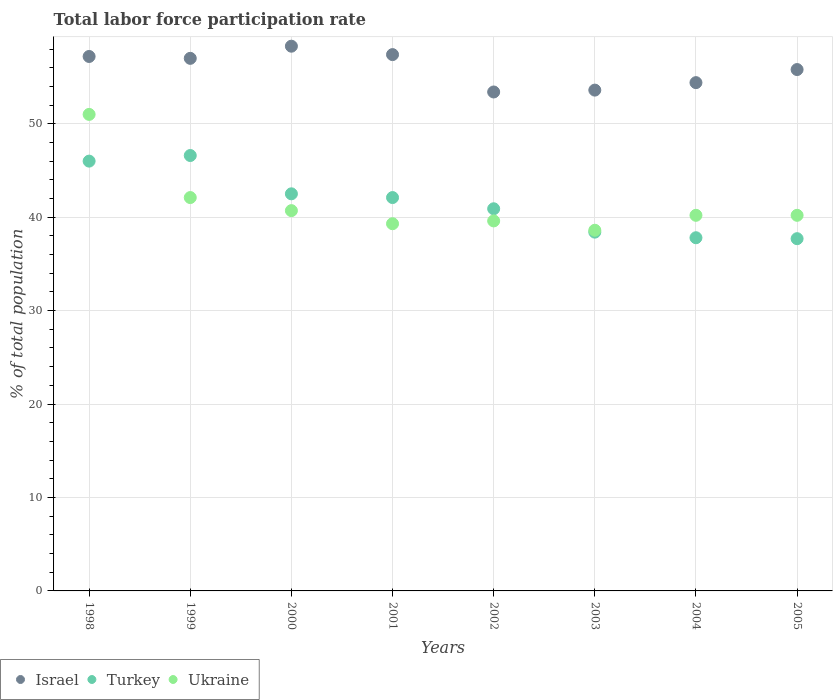How many different coloured dotlines are there?
Your response must be concise. 3. What is the total labor force participation rate in Turkey in 2004?
Keep it short and to the point. 37.8. Across all years, what is the maximum total labor force participation rate in Turkey?
Your answer should be very brief. 46.6. Across all years, what is the minimum total labor force participation rate in Ukraine?
Offer a very short reply. 38.6. In which year was the total labor force participation rate in Israel maximum?
Give a very brief answer. 2000. In which year was the total labor force participation rate in Israel minimum?
Your response must be concise. 2002. What is the total total labor force participation rate in Israel in the graph?
Your answer should be very brief. 447.1. What is the difference between the total labor force participation rate in Israel in 1999 and that in 2001?
Make the answer very short. -0.4. What is the difference between the total labor force participation rate in Ukraine in 1998 and the total labor force participation rate in Israel in 2000?
Your response must be concise. -7.3. What is the average total labor force participation rate in Ukraine per year?
Ensure brevity in your answer.  41.46. In the year 2001, what is the difference between the total labor force participation rate in Israel and total labor force participation rate in Ukraine?
Make the answer very short. 18.1. What is the ratio of the total labor force participation rate in Ukraine in 1999 to that in 2005?
Keep it short and to the point. 1.05. What is the difference between the highest and the second highest total labor force participation rate in Ukraine?
Ensure brevity in your answer.  8.9. What is the difference between the highest and the lowest total labor force participation rate in Israel?
Make the answer very short. 4.9. In how many years, is the total labor force participation rate in Turkey greater than the average total labor force participation rate in Turkey taken over all years?
Offer a very short reply. 4. Is the sum of the total labor force participation rate in Israel in 1998 and 2001 greater than the maximum total labor force participation rate in Ukraine across all years?
Offer a terse response. Yes. Is the total labor force participation rate in Ukraine strictly greater than the total labor force participation rate in Israel over the years?
Your answer should be very brief. No. Is the total labor force participation rate in Israel strictly less than the total labor force participation rate in Turkey over the years?
Ensure brevity in your answer.  No. How many years are there in the graph?
Your answer should be compact. 8. What is the difference between two consecutive major ticks on the Y-axis?
Give a very brief answer. 10. What is the title of the graph?
Ensure brevity in your answer.  Total labor force participation rate. Does "Chile" appear as one of the legend labels in the graph?
Provide a succinct answer. No. What is the label or title of the X-axis?
Provide a succinct answer. Years. What is the label or title of the Y-axis?
Offer a very short reply. % of total population. What is the % of total population of Israel in 1998?
Your response must be concise. 57.2. What is the % of total population in Ukraine in 1998?
Keep it short and to the point. 51. What is the % of total population of Israel in 1999?
Your answer should be compact. 57. What is the % of total population of Turkey in 1999?
Ensure brevity in your answer.  46.6. What is the % of total population of Ukraine in 1999?
Your response must be concise. 42.1. What is the % of total population of Israel in 2000?
Provide a succinct answer. 58.3. What is the % of total population of Turkey in 2000?
Make the answer very short. 42.5. What is the % of total population of Ukraine in 2000?
Your answer should be compact. 40.7. What is the % of total population in Israel in 2001?
Provide a short and direct response. 57.4. What is the % of total population in Turkey in 2001?
Provide a succinct answer. 42.1. What is the % of total population in Ukraine in 2001?
Provide a short and direct response. 39.3. What is the % of total population of Israel in 2002?
Make the answer very short. 53.4. What is the % of total population in Turkey in 2002?
Give a very brief answer. 40.9. What is the % of total population in Ukraine in 2002?
Ensure brevity in your answer.  39.6. What is the % of total population of Israel in 2003?
Keep it short and to the point. 53.6. What is the % of total population in Turkey in 2003?
Your response must be concise. 38.4. What is the % of total population in Ukraine in 2003?
Your answer should be very brief. 38.6. What is the % of total population of Israel in 2004?
Offer a terse response. 54.4. What is the % of total population of Turkey in 2004?
Provide a succinct answer. 37.8. What is the % of total population of Ukraine in 2004?
Offer a very short reply. 40.2. What is the % of total population of Israel in 2005?
Offer a terse response. 55.8. What is the % of total population in Turkey in 2005?
Your answer should be very brief. 37.7. What is the % of total population in Ukraine in 2005?
Your answer should be very brief. 40.2. Across all years, what is the maximum % of total population of Israel?
Your answer should be very brief. 58.3. Across all years, what is the maximum % of total population in Turkey?
Make the answer very short. 46.6. Across all years, what is the maximum % of total population of Ukraine?
Your response must be concise. 51. Across all years, what is the minimum % of total population in Israel?
Ensure brevity in your answer.  53.4. Across all years, what is the minimum % of total population in Turkey?
Provide a succinct answer. 37.7. Across all years, what is the minimum % of total population in Ukraine?
Your answer should be very brief. 38.6. What is the total % of total population in Israel in the graph?
Your response must be concise. 447.1. What is the total % of total population of Turkey in the graph?
Your answer should be compact. 332. What is the total % of total population in Ukraine in the graph?
Offer a very short reply. 331.7. What is the difference between the % of total population of Israel in 1998 and that in 1999?
Provide a succinct answer. 0.2. What is the difference between the % of total population of Turkey in 1998 and that in 1999?
Ensure brevity in your answer.  -0.6. What is the difference between the % of total population of Ukraine in 1998 and that in 1999?
Offer a terse response. 8.9. What is the difference between the % of total population in Israel in 1998 and that in 2000?
Keep it short and to the point. -1.1. What is the difference between the % of total population of Turkey in 1998 and that in 2000?
Your answer should be compact. 3.5. What is the difference between the % of total population in Ukraine in 1998 and that in 2001?
Provide a short and direct response. 11.7. What is the difference between the % of total population of Israel in 1998 and that in 2003?
Offer a terse response. 3.6. What is the difference between the % of total population in Ukraine in 1998 and that in 2003?
Provide a short and direct response. 12.4. What is the difference between the % of total population of Israel in 1998 and that in 2004?
Ensure brevity in your answer.  2.8. What is the difference between the % of total population of Israel in 1998 and that in 2005?
Provide a short and direct response. 1.4. What is the difference between the % of total population of Ukraine in 1998 and that in 2005?
Offer a terse response. 10.8. What is the difference between the % of total population in Turkey in 1999 and that in 2000?
Ensure brevity in your answer.  4.1. What is the difference between the % of total population of Israel in 1999 and that in 2001?
Offer a very short reply. -0.4. What is the difference between the % of total population of Ukraine in 1999 and that in 2001?
Your response must be concise. 2.8. What is the difference between the % of total population in Israel in 1999 and that in 2002?
Offer a terse response. 3.6. What is the difference between the % of total population in Israel in 1999 and that in 2003?
Offer a very short reply. 3.4. What is the difference between the % of total population in Turkey in 1999 and that in 2003?
Offer a very short reply. 8.2. What is the difference between the % of total population in Ukraine in 1999 and that in 2003?
Offer a terse response. 3.5. What is the difference between the % of total population in Israel in 1999 and that in 2004?
Offer a very short reply. 2.6. What is the difference between the % of total population of Turkey in 1999 and that in 2004?
Offer a very short reply. 8.8. What is the difference between the % of total population in Turkey in 1999 and that in 2005?
Give a very brief answer. 8.9. What is the difference between the % of total population in Turkey in 2000 and that in 2001?
Your response must be concise. 0.4. What is the difference between the % of total population of Ukraine in 2000 and that in 2001?
Make the answer very short. 1.4. What is the difference between the % of total population of Israel in 2000 and that in 2002?
Provide a short and direct response. 4.9. What is the difference between the % of total population of Ukraine in 2000 and that in 2002?
Give a very brief answer. 1.1. What is the difference between the % of total population in Israel in 2000 and that in 2003?
Keep it short and to the point. 4.7. What is the difference between the % of total population in Turkey in 2000 and that in 2003?
Your answer should be compact. 4.1. What is the difference between the % of total population of Ukraine in 2000 and that in 2003?
Ensure brevity in your answer.  2.1. What is the difference between the % of total population in Israel in 2000 and that in 2004?
Offer a terse response. 3.9. What is the difference between the % of total population in Ukraine in 2000 and that in 2004?
Ensure brevity in your answer.  0.5. What is the difference between the % of total population of Israel in 2000 and that in 2005?
Your answer should be very brief. 2.5. What is the difference between the % of total population in Turkey in 2000 and that in 2005?
Offer a terse response. 4.8. What is the difference between the % of total population in Israel in 2001 and that in 2002?
Make the answer very short. 4. What is the difference between the % of total population in Turkey in 2001 and that in 2002?
Offer a very short reply. 1.2. What is the difference between the % of total population in Israel in 2001 and that in 2003?
Keep it short and to the point. 3.8. What is the difference between the % of total population of Israel in 2001 and that in 2004?
Keep it short and to the point. 3. What is the difference between the % of total population of Turkey in 2001 and that in 2004?
Give a very brief answer. 4.3. What is the difference between the % of total population in Ukraine in 2001 and that in 2004?
Your answer should be very brief. -0.9. What is the difference between the % of total population in Israel in 2001 and that in 2005?
Your answer should be compact. 1.6. What is the difference between the % of total population in Turkey in 2001 and that in 2005?
Give a very brief answer. 4.4. What is the difference between the % of total population of Turkey in 2002 and that in 2004?
Your answer should be very brief. 3.1. What is the difference between the % of total population in Ukraine in 2002 and that in 2004?
Provide a succinct answer. -0.6. What is the difference between the % of total population in Israel in 2002 and that in 2005?
Give a very brief answer. -2.4. What is the difference between the % of total population of Turkey in 2002 and that in 2005?
Your answer should be compact. 3.2. What is the difference between the % of total population in Ukraine in 2003 and that in 2004?
Make the answer very short. -1.6. What is the difference between the % of total population of Ukraine in 2003 and that in 2005?
Offer a terse response. -1.6. What is the difference between the % of total population in Israel in 2004 and that in 2005?
Ensure brevity in your answer.  -1.4. What is the difference between the % of total population of Turkey in 2004 and that in 2005?
Provide a short and direct response. 0.1. What is the difference between the % of total population of Israel in 1998 and the % of total population of Turkey in 1999?
Your answer should be compact. 10.6. What is the difference between the % of total population in Israel in 1998 and the % of total population in Turkey in 2000?
Offer a very short reply. 14.7. What is the difference between the % of total population of Israel in 1998 and the % of total population of Ukraine in 2000?
Your answer should be compact. 16.5. What is the difference between the % of total population of Israel in 1998 and the % of total population of Turkey in 2001?
Offer a terse response. 15.1. What is the difference between the % of total population in Israel in 1998 and the % of total population in Ukraine in 2001?
Provide a succinct answer. 17.9. What is the difference between the % of total population of Turkey in 1998 and the % of total population of Ukraine in 2002?
Keep it short and to the point. 6.4. What is the difference between the % of total population in Israel in 1998 and the % of total population in Turkey in 2003?
Keep it short and to the point. 18.8. What is the difference between the % of total population in Turkey in 1998 and the % of total population in Ukraine in 2003?
Provide a short and direct response. 7.4. What is the difference between the % of total population in Israel in 1998 and the % of total population in Turkey in 2004?
Your response must be concise. 19.4. What is the difference between the % of total population in Turkey in 1998 and the % of total population in Ukraine in 2004?
Provide a short and direct response. 5.8. What is the difference between the % of total population of Israel in 1999 and the % of total population of Turkey in 2000?
Make the answer very short. 14.5. What is the difference between the % of total population of Turkey in 1999 and the % of total population of Ukraine in 2000?
Make the answer very short. 5.9. What is the difference between the % of total population of Israel in 1999 and the % of total population of Turkey in 2001?
Make the answer very short. 14.9. What is the difference between the % of total population of Turkey in 1999 and the % of total population of Ukraine in 2001?
Your response must be concise. 7.3. What is the difference between the % of total population in Israel in 1999 and the % of total population in Turkey in 2002?
Offer a very short reply. 16.1. What is the difference between the % of total population in Turkey in 1999 and the % of total population in Ukraine in 2002?
Give a very brief answer. 7. What is the difference between the % of total population in Turkey in 1999 and the % of total population in Ukraine in 2003?
Offer a very short reply. 8. What is the difference between the % of total population in Israel in 1999 and the % of total population in Turkey in 2005?
Your answer should be very brief. 19.3. What is the difference between the % of total population of Israel in 2000 and the % of total population of Turkey in 2004?
Give a very brief answer. 20.5. What is the difference between the % of total population in Israel in 2000 and the % of total population in Ukraine in 2004?
Your response must be concise. 18.1. What is the difference between the % of total population of Israel in 2000 and the % of total population of Turkey in 2005?
Offer a terse response. 20.6. What is the difference between the % of total population in Israel in 2000 and the % of total population in Ukraine in 2005?
Your answer should be very brief. 18.1. What is the difference between the % of total population of Turkey in 2001 and the % of total population of Ukraine in 2002?
Provide a succinct answer. 2.5. What is the difference between the % of total population of Israel in 2001 and the % of total population of Turkey in 2003?
Your answer should be compact. 19. What is the difference between the % of total population in Israel in 2001 and the % of total population in Ukraine in 2003?
Offer a very short reply. 18.8. What is the difference between the % of total population of Turkey in 2001 and the % of total population of Ukraine in 2003?
Ensure brevity in your answer.  3.5. What is the difference between the % of total population in Israel in 2001 and the % of total population in Turkey in 2004?
Offer a very short reply. 19.6. What is the difference between the % of total population of Turkey in 2001 and the % of total population of Ukraine in 2004?
Provide a succinct answer. 1.9. What is the difference between the % of total population of Israel in 2001 and the % of total population of Ukraine in 2005?
Offer a very short reply. 17.2. What is the difference between the % of total population in Turkey in 2001 and the % of total population in Ukraine in 2005?
Your answer should be very brief. 1.9. What is the difference between the % of total population in Israel in 2002 and the % of total population in Turkey in 2003?
Your answer should be compact. 15. What is the difference between the % of total population in Israel in 2002 and the % of total population in Ukraine in 2003?
Offer a very short reply. 14.8. What is the difference between the % of total population in Israel in 2002 and the % of total population in Turkey in 2004?
Give a very brief answer. 15.6. What is the difference between the % of total population in Turkey in 2002 and the % of total population in Ukraine in 2004?
Your answer should be very brief. 0.7. What is the difference between the % of total population of Israel in 2002 and the % of total population of Turkey in 2005?
Provide a succinct answer. 15.7. What is the difference between the % of total population of Israel in 2002 and the % of total population of Ukraine in 2005?
Provide a short and direct response. 13.2. What is the difference between the % of total population of Israel in 2003 and the % of total population of Turkey in 2004?
Provide a short and direct response. 15.8. What is the difference between the % of total population of Israel in 2003 and the % of total population of Turkey in 2005?
Make the answer very short. 15.9. What is the difference between the % of total population of Turkey in 2003 and the % of total population of Ukraine in 2005?
Make the answer very short. -1.8. What is the difference between the % of total population in Israel in 2004 and the % of total population in Turkey in 2005?
Your answer should be very brief. 16.7. What is the difference between the % of total population of Israel in 2004 and the % of total population of Ukraine in 2005?
Provide a succinct answer. 14.2. What is the difference between the % of total population of Turkey in 2004 and the % of total population of Ukraine in 2005?
Your answer should be very brief. -2.4. What is the average % of total population of Israel per year?
Make the answer very short. 55.89. What is the average % of total population in Turkey per year?
Offer a very short reply. 41.5. What is the average % of total population in Ukraine per year?
Give a very brief answer. 41.46. In the year 1998, what is the difference between the % of total population of Israel and % of total population of Turkey?
Offer a terse response. 11.2. In the year 1998, what is the difference between the % of total population of Israel and % of total population of Ukraine?
Your answer should be compact. 6.2. In the year 1999, what is the difference between the % of total population in Turkey and % of total population in Ukraine?
Offer a terse response. 4.5. In the year 2000, what is the difference between the % of total population in Israel and % of total population in Ukraine?
Ensure brevity in your answer.  17.6. In the year 2000, what is the difference between the % of total population of Turkey and % of total population of Ukraine?
Your answer should be very brief. 1.8. In the year 2001, what is the difference between the % of total population of Turkey and % of total population of Ukraine?
Offer a very short reply. 2.8. In the year 2002, what is the difference between the % of total population of Israel and % of total population of Turkey?
Give a very brief answer. 12.5. In the year 2002, what is the difference between the % of total population of Israel and % of total population of Ukraine?
Ensure brevity in your answer.  13.8. In the year 2003, what is the difference between the % of total population of Israel and % of total population of Turkey?
Provide a succinct answer. 15.2. In the year 2003, what is the difference between the % of total population in Israel and % of total population in Ukraine?
Make the answer very short. 15. In the year 2004, what is the difference between the % of total population in Israel and % of total population in Turkey?
Offer a terse response. 16.6. In the year 2005, what is the difference between the % of total population of Israel and % of total population of Turkey?
Provide a short and direct response. 18.1. In the year 2005, what is the difference between the % of total population of Israel and % of total population of Ukraine?
Provide a succinct answer. 15.6. What is the ratio of the % of total population of Turkey in 1998 to that in 1999?
Provide a short and direct response. 0.99. What is the ratio of the % of total population in Ukraine in 1998 to that in 1999?
Your answer should be very brief. 1.21. What is the ratio of the % of total population of Israel in 1998 to that in 2000?
Keep it short and to the point. 0.98. What is the ratio of the % of total population of Turkey in 1998 to that in 2000?
Your answer should be very brief. 1.08. What is the ratio of the % of total population of Ukraine in 1998 to that in 2000?
Provide a succinct answer. 1.25. What is the ratio of the % of total population of Israel in 1998 to that in 2001?
Your answer should be compact. 1. What is the ratio of the % of total population of Turkey in 1998 to that in 2001?
Keep it short and to the point. 1.09. What is the ratio of the % of total population of Ukraine in 1998 to that in 2001?
Ensure brevity in your answer.  1.3. What is the ratio of the % of total population of Israel in 1998 to that in 2002?
Give a very brief answer. 1.07. What is the ratio of the % of total population in Turkey in 1998 to that in 2002?
Your response must be concise. 1.12. What is the ratio of the % of total population of Ukraine in 1998 to that in 2002?
Your answer should be compact. 1.29. What is the ratio of the % of total population in Israel in 1998 to that in 2003?
Ensure brevity in your answer.  1.07. What is the ratio of the % of total population of Turkey in 1998 to that in 2003?
Your answer should be very brief. 1.2. What is the ratio of the % of total population in Ukraine in 1998 to that in 2003?
Ensure brevity in your answer.  1.32. What is the ratio of the % of total population of Israel in 1998 to that in 2004?
Your response must be concise. 1.05. What is the ratio of the % of total population of Turkey in 1998 to that in 2004?
Provide a succinct answer. 1.22. What is the ratio of the % of total population of Ukraine in 1998 to that in 2004?
Ensure brevity in your answer.  1.27. What is the ratio of the % of total population in Israel in 1998 to that in 2005?
Ensure brevity in your answer.  1.03. What is the ratio of the % of total population in Turkey in 1998 to that in 2005?
Keep it short and to the point. 1.22. What is the ratio of the % of total population of Ukraine in 1998 to that in 2005?
Your answer should be compact. 1.27. What is the ratio of the % of total population of Israel in 1999 to that in 2000?
Provide a succinct answer. 0.98. What is the ratio of the % of total population in Turkey in 1999 to that in 2000?
Give a very brief answer. 1.1. What is the ratio of the % of total population of Ukraine in 1999 to that in 2000?
Make the answer very short. 1.03. What is the ratio of the % of total population of Turkey in 1999 to that in 2001?
Give a very brief answer. 1.11. What is the ratio of the % of total population in Ukraine in 1999 to that in 2001?
Your answer should be compact. 1.07. What is the ratio of the % of total population of Israel in 1999 to that in 2002?
Provide a short and direct response. 1.07. What is the ratio of the % of total population of Turkey in 1999 to that in 2002?
Ensure brevity in your answer.  1.14. What is the ratio of the % of total population of Ukraine in 1999 to that in 2002?
Offer a very short reply. 1.06. What is the ratio of the % of total population of Israel in 1999 to that in 2003?
Offer a terse response. 1.06. What is the ratio of the % of total population of Turkey in 1999 to that in 2003?
Provide a succinct answer. 1.21. What is the ratio of the % of total population of Ukraine in 1999 to that in 2003?
Your response must be concise. 1.09. What is the ratio of the % of total population of Israel in 1999 to that in 2004?
Provide a short and direct response. 1.05. What is the ratio of the % of total population in Turkey in 1999 to that in 2004?
Provide a succinct answer. 1.23. What is the ratio of the % of total population in Ukraine in 1999 to that in 2004?
Offer a very short reply. 1.05. What is the ratio of the % of total population in Israel in 1999 to that in 2005?
Offer a very short reply. 1.02. What is the ratio of the % of total population in Turkey in 1999 to that in 2005?
Provide a short and direct response. 1.24. What is the ratio of the % of total population of Ukraine in 1999 to that in 2005?
Make the answer very short. 1.05. What is the ratio of the % of total population of Israel in 2000 to that in 2001?
Give a very brief answer. 1.02. What is the ratio of the % of total population in Turkey in 2000 to that in 2001?
Make the answer very short. 1.01. What is the ratio of the % of total population of Ukraine in 2000 to that in 2001?
Your response must be concise. 1.04. What is the ratio of the % of total population of Israel in 2000 to that in 2002?
Provide a succinct answer. 1.09. What is the ratio of the % of total population in Turkey in 2000 to that in 2002?
Ensure brevity in your answer.  1.04. What is the ratio of the % of total population of Ukraine in 2000 to that in 2002?
Give a very brief answer. 1.03. What is the ratio of the % of total population in Israel in 2000 to that in 2003?
Keep it short and to the point. 1.09. What is the ratio of the % of total population in Turkey in 2000 to that in 2003?
Your answer should be very brief. 1.11. What is the ratio of the % of total population of Ukraine in 2000 to that in 2003?
Give a very brief answer. 1.05. What is the ratio of the % of total population in Israel in 2000 to that in 2004?
Your answer should be very brief. 1.07. What is the ratio of the % of total population of Turkey in 2000 to that in 2004?
Your response must be concise. 1.12. What is the ratio of the % of total population of Ukraine in 2000 to that in 2004?
Your answer should be compact. 1.01. What is the ratio of the % of total population of Israel in 2000 to that in 2005?
Provide a short and direct response. 1.04. What is the ratio of the % of total population in Turkey in 2000 to that in 2005?
Offer a terse response. 1.13. What is the ratio of the % of total population in Ukraine in 2000 to that in 2005?
Provide a short and direct response. 1.01. What is the ratio of the % of total population in Israel in 2001 to that in 2002?
Keep it short and to the point. 1.07. What is the ratio of the % of total population of Turkey in 2001 to that in 2002?
Your answer should be very brief. 1.03. What is the ratio of the % of total population in Israel in 2001 to that in 2003?
Ensure brevity in your answer.  1.07. What is the ratio of the % of total population of Turkey in 2001 to that in 2003?
Give a very brief answer. 1.1. What is the ratio of the % of total population in Ukraine in 2001 to that in 2003?
Provide a short and direct response. 1.02. What is the ratio of the % of total population of Israel in 2001 to that in 2004?
Provide a succinct answer. 1.06. What is the ratio of the % of total population of Turkey in 2001 to that in 2004?
Provide a short and direct response. 1.11. What is the ratio of the % of total population in Ukraine in 2001 to that in 2004?
Give a very brief answer. 0.98. What is the ratio of the % of total population in Israel in 2001 to that in 2005?
Your response must be concise. 1.03. What is the ratio of the % of total population in Turkey in 2001 to that in 2005?
Make the answer very short. 1.12. What is the ratio of the % of total population in Ukraine in 2001 to that in 2005?
Offer a terse response. 0.98. What is the ratio of the % of total population in Israel in 2002 to that in 2003?
Provide a succinct answer. 1. What is the ratio of the % of total population in Turkey in 2002 to that in 2003?
Give a very brief answer. 1.07. What is the ratio of the % of total population of Ukraine in 2002 to that in 2003?
Provide a succinct answer. 1.03. What is the ratio of the % of total population in Israel in 2002 to that in 2004?
Your answer should be very brief. 0.98. What is the ratio of the % of total population of Turkey in 2002 to that in 2004?
Provide a short and direct response. 1.08. What is the ratio of the % of total population of Ukraine in 2002 to that in 2004?
Provide a short and direct response. 0.99. What is the ratio of the % of total population in Israel in 2002 to that in 2005?
Provide a short and direct response. 0.96. What is the ratio of the % of total population in Turkey in 2002 to that in 2005?
Offer a very short reply. 1.08. What is the ratio of the % of total population of Ukraine in 2002 to that in 2005?
Give a very brief answer. 0.99. What is the ratio of the % of total population in Israel in 2003 to that in 2004?
Keep it short and to the point. 0.99. What is the ratio of the % of total population in Turkey in 2003 to that in 2004?
Offer a terse response. 1.02. What is the ratio of the % of total population in Ukraine in 2003 to that in 2004?
Ensure brevity in your answer.  0.96. What is the ratio of the % of total population in Israel in 2003 to that in 2005?
Give a very brief answer. 0.96. What is the ratio of the % of total population in Turkey in 2003 to that in 2005?
Give a very brief answer. 1.02. What is the ratio of the % of total population in Ukraine in 2003 to that in 2005?
Offer a terse response. 0.96. What is the ratio of the % of total population in Israel in 2004 to that in 2005?
Offer a terse response. 0.97. What is the ratio of the % of total population in Ukraine in 2004 to that in 2005?
Your answer should be very brief. 1. What is the difference between the highest and the second highest % of total population in Israel?
Offer a very short reply. 0.9. What is the difference between the highest and the second highest % of total population of Turkey?
Make the answer very short. 0.6. 